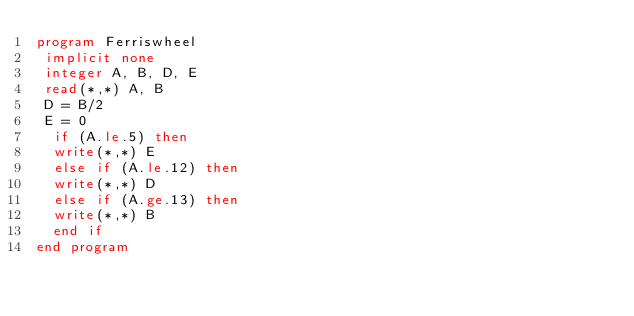<code> <loc_0><loc_0><loc_500><loc_500><_FORTRAN_>program Ferriswheel
 implicit none
 integer A, B, D, E
 read(*,*) A, B
 D = B/2
 E = 0
  if (A.le.5) then
  write(*,*) E
  else if (A.le.12) then
  write(*,*) D
  else if (A.ge.13) then
  write(*,*) B
  end if
end program</code> 